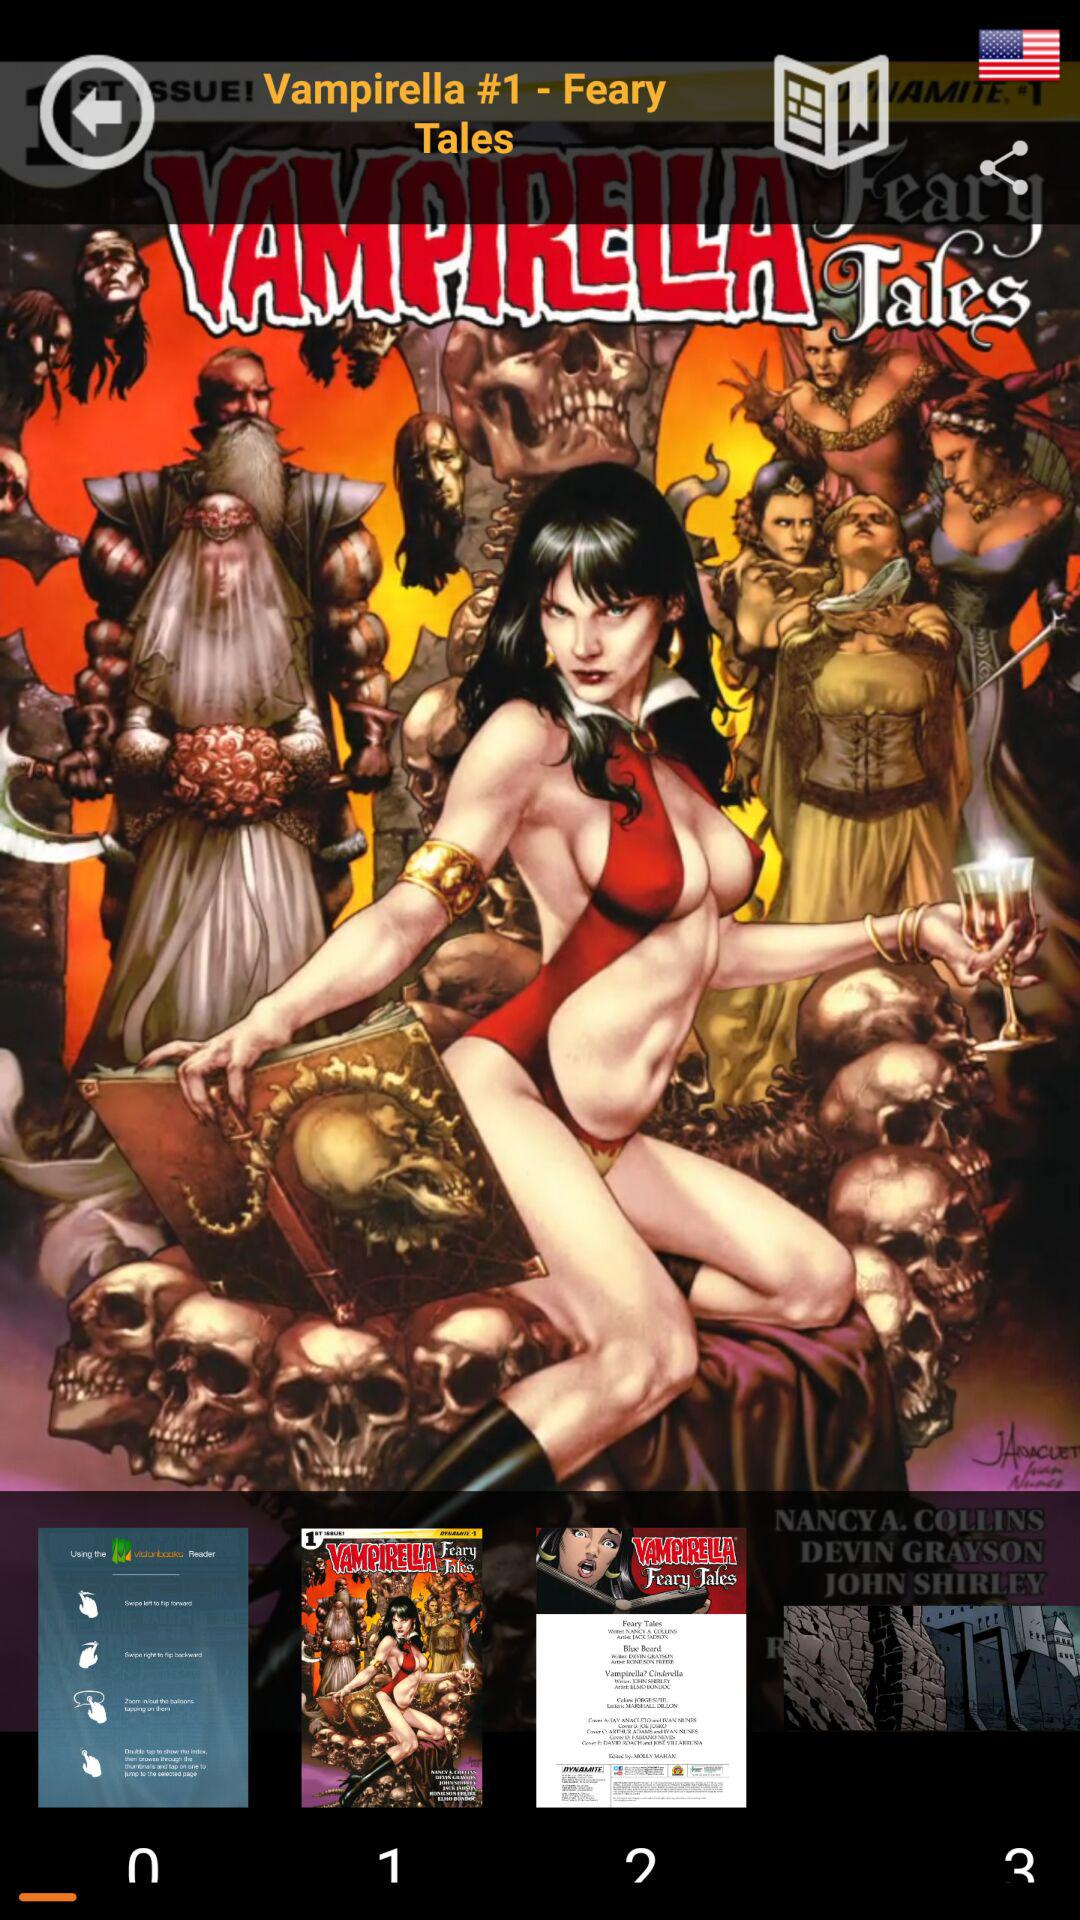What is a "Vampirella"? It is a feary tale. 